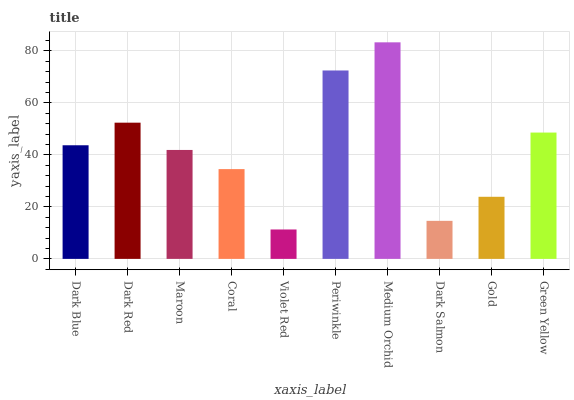Is Violet Red the minimum?
Answer yes or no. Yes. Is Medium Orchid the maximum?
Answer yes or no. Yes. Is Dark Red the minimum?
Answer yes or no. No. Is Dark Red the maximum?
Answer yes or no. No. Is Dark Red greater than Dark Blue?
Answer yes or no. Yes. Is Dark Blue less than Dark Red?
Answer yes or no. Yes. Is Dark Blue greater than Dark Red?
Answer yes or no. No. Is Dark Red less than Dark Blue?
Answer yes or no. No. Is Dark Blue the high median?
Answer yes or no. Yes. Is Maroon the low median?
Answer yes or no. Yes. Is Dark Salmon the high median?
Answer yes or no. No. Is Dark Red the low median?
Answer yes or no. No. 